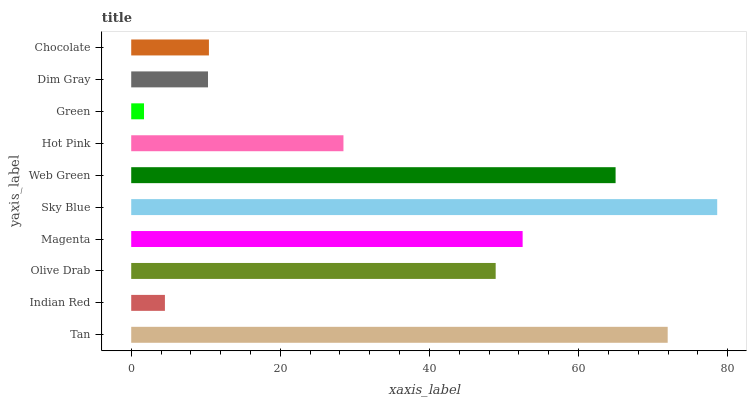Is Green the minimum?
Answer yes or no. Yes. Is Sky Blue the maximum?
Answer yes or no. Yes. Is Indian Red the minimum?
Answer yes or no. No. Is Indian Red the maximum?
Answer yes or no. No. Is Tan greater than Indian Red?
Answer yes or no. Yes. Is Indian Red less than Tan?
Answer yes or no. Yes. Is Indian Red greater than Tan?
Answer yes or no. No. Is Tan less than Indian Red?
Answer yes or no. No. Is Olive Drab the high median?
Answer yes or no. Yes. Is Hot Pink the low median?
Answer yes or no. Yes. Is Dim Gray the high median?
Answer yes or no. No. Is Sky Blue the low median?
Answer yes or no. No. 